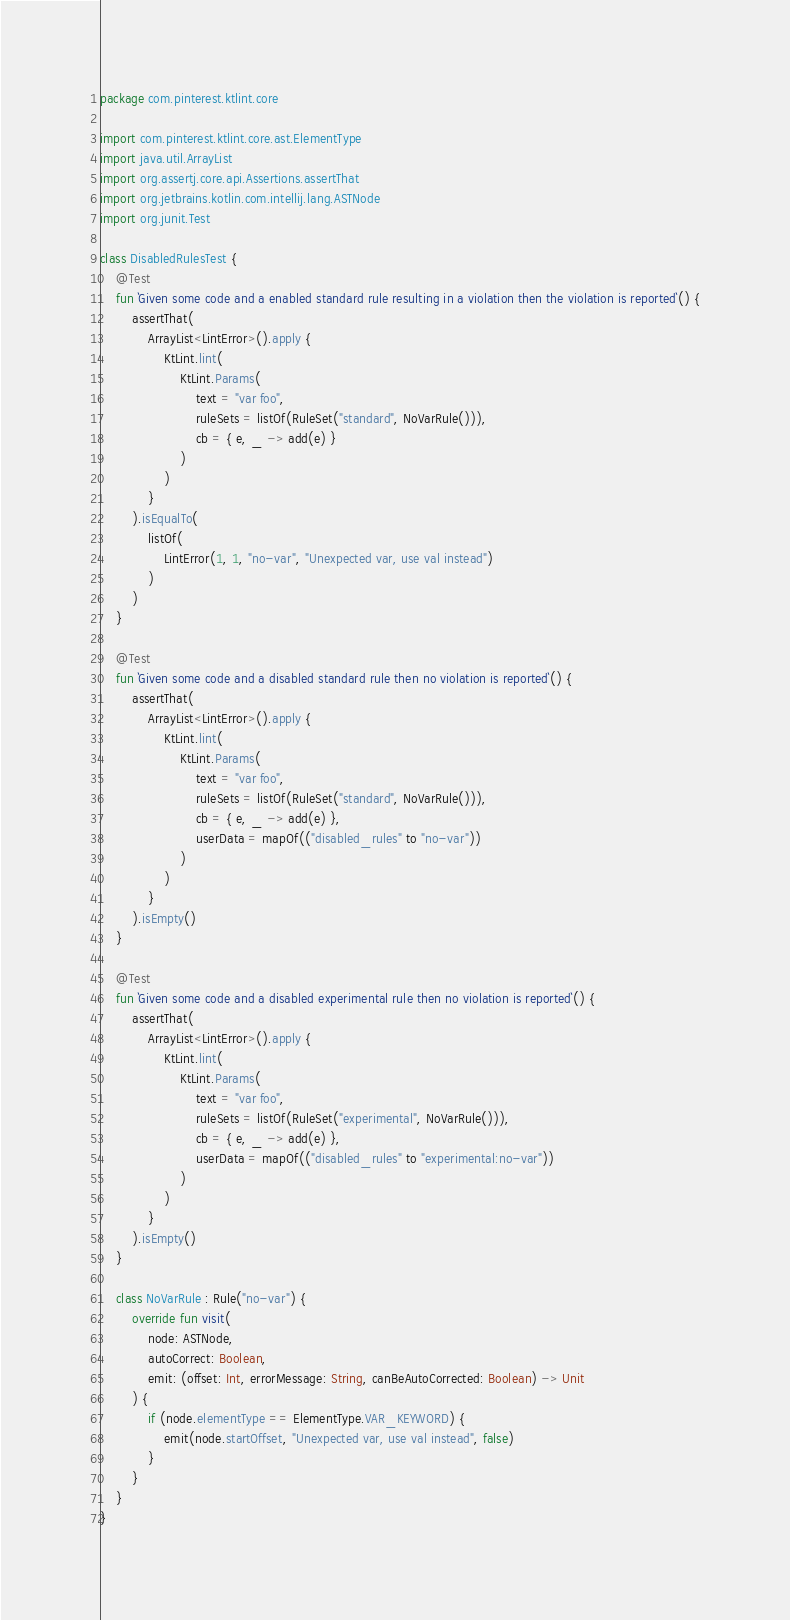Convert code to text. <code><loc_0><loc_0><loc_500><loc_500><_Kotlin_>package com.pinterest.ktlint.core

import com.pinterest.ktlint.core.ast.ElementType
import java.util.ArrayList
import org.assertj.core.api.Assertions.assertThat
import org.jetbrains.kotlin.com.intellij.lang.ASTNode
import org.junit.Test

class DisabledRulesTest {
    @Test
    fun `Given some code and a enabled standard rule resulting in a violation then the violation is reported`() {
        assertThat(
            ArrayList<LintError>().apply {
                KtLint.lint(
                    KtLint.Params(
                        text = "var foo",
                        ruleSets = listOf(RuleSet("standard", NoVarRule())),
                        cb = { e, _ -> add(e) }
                    )
                )
            }
        ).isEqualTo(
            listOf(
                LintError(1, 1, "no-var", "Unexpected var, use val instead")
            )
        )
    }

    @Test
    fun `Given some code and a disabled standard rule then no violation is reported`() {
        assertThat(
            ArrayList<LintError>().apply {
                KtLint.lint(
                    KtLint.Params(
                        text = "var foo",
                        ruleSets = listOf(RuleSet("standard", NoVarRule())),
                        cb = { e, _ -> add(e) },
                        userData = mapOf(("disabled_rules" to "no-var"))
                    )
                )
            }
        ).isEmpty()
    }

    @Test
    fun `Given some code and a disabled experimental rule then no violation is reported`() {
        assertThat(
            ArrayList<LintError>().apply {
                KtLint.lint(
                    KtLint.Params(
                        text = "var foo",
                        ruleSets = listOf(RuleSet("experimental", NoVarRule())),
                        cb = { e, _ -> add(e) },
                        userData = mapOf(("disabled_rules" to "experimental:no-var"))
                    )
                )
            }
        ).isEmpty()
    }

    class NoVarRule : Rule("no-var") {
        override fun visit(
            node: ASTNode,
            autoCorrect: Boolean,
            emit: (offset: Int, errorMessage: String, canBeAutoCorrected: Boolean) -> Unit
        ) {
            if (node.elementType == ElementType.VAR_KEYWORD) {
                emit(node.startOffset, "Unexpected var, use val instead", false)
            }
        }
    }
}
</code> 